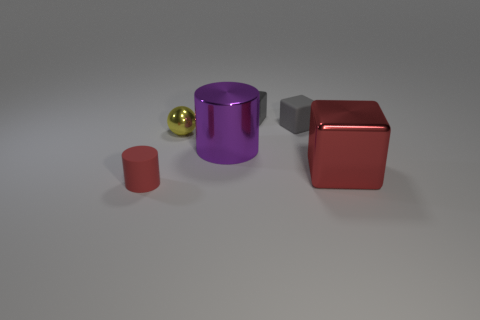Subtract all small cubes. How many cubes are left? 1 Add 2 cyan cubes. How many objects exist? 8 Subtract all purple cylinders. How many cylinders are left? 1 Subtract 2 cylinders. How many cylinders are left? 0 Subtract all cylinders. How many objects are left? 4 Subtract all green blocks. Subtract all purple cylinders. How many blocks are left? 3 Subtract all blue cylinders. How many gray blocks are left? 2 Subtract all gray shiny cubes. Subtract all spheres. How many objects are left? 4 Add 4 gray things. How many gray things are left? 6 Add 1 small purple cylinders. How many small purple cylinders exist? 1 